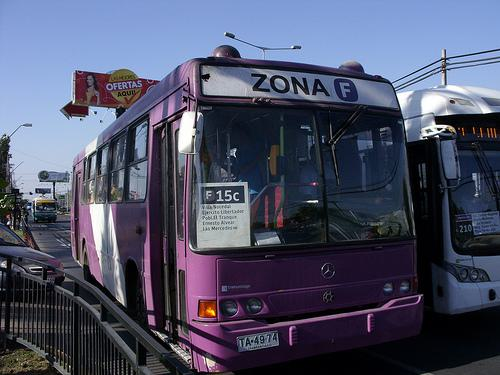How many cars are there in the image? Upon reviewing the image, it appears that there are no cars visible in the immediate vicinity. The focus of the image is a purple bus marked with 'Zona F' which suggests it's part of a transit service. The presence of other buses in the background can be noted, but no cars are discernible in this particular frame. 